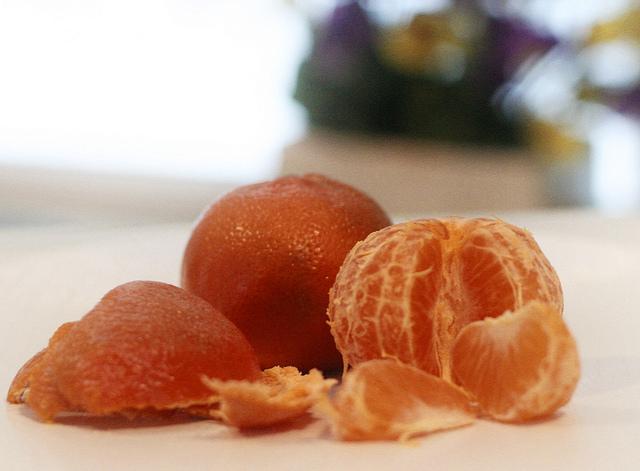Is this a healthy snack?
Be succinct. Yes. What is different about one of these oranges?
Give a very brief answer. Peeled. How many slices are out of the orange?
Concise answer only. 2. How many people are eating?
Concise answer only. 0. Is one orange peeled?
Keep it brief. Yes. 